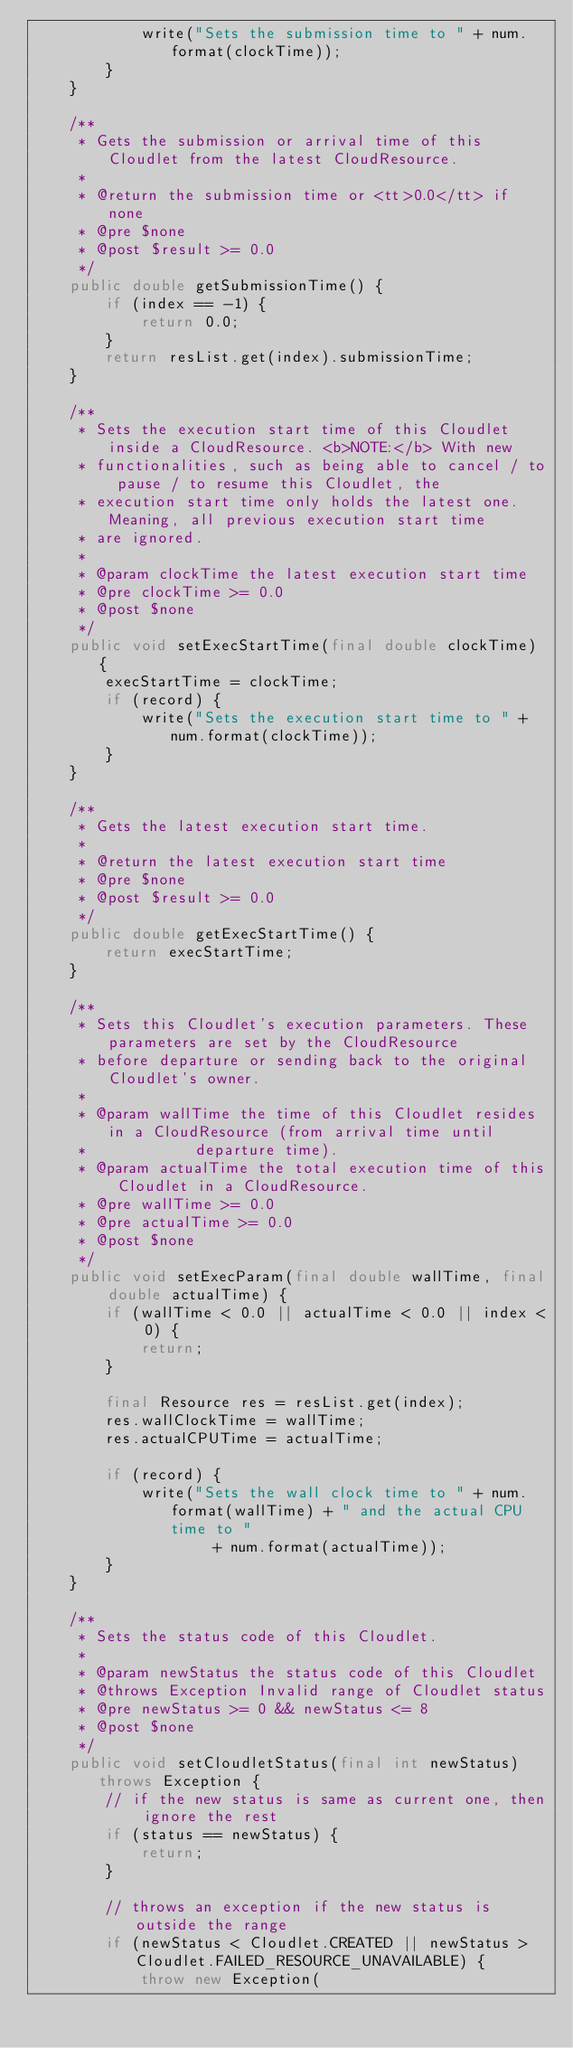Convert code to text. <code><loc_0><loc_0><loc_500><loc_500><_Java_>			write("Sets the submission time to " + num.format(clockTime));
		}
	}

	/**
	 * Gets the submission or arrival time of this Cloudlet from the latest CloudResource.
	 * 
	 * @return the submission time or <tt>0.0</tt> if none
	 * @pre $none
	 * @post $result >= 0.0
	 */
	public double getSubmissionTime() {
		if (index == -1) {
			return 0.0;
		}
		return resList.get(index).submissionTime;
	}

	/**
	 * Sets the execution start time of this Cloudlet inside a CloudResource. <b>NOTE:</b> With new
	 * functionalities, such as being able to cancel / to pause / to resume this Cloudlet, the
	 * execution start time only holds the latest one. Meaning, all previous execution start time
	 * are ignored.
	 * 
	 * @param clockTime the latest execution start time
	 * @pre clockTime >= 0.0
	 * @post $none
	 */
	public void setExecStartTime(final double clockTime) {
		execStartTime = clockTime;
		if (record) {
			write("Sets the execution start time to " + num.format(clockTime));
		}
	}

	/**
	 * Gets the latest execution start time.
	 * 
	 * @return the latest execution start time
	 * @pre $none
	 * @post $result >= 0.0
	 */
	public double getExecStartTime() {
		return execStartTime;
	}

	/**
	 * Sets this Cloudlet's execution parameters. These parameters are set by the CloudResource
	 * before departure or sending back to the original Cloudlet's owner.
	 * 
	 * @param wallTime the time of this Cloudlet resides in a CloudResource (from arrival time until
	 *            departure time).
	 * @param actualTime the total execution time of this Cloudlet in a CloudResource.
	 * @pre wallTime >= 0.0
	 * @pre actualTime >= 0.0
	 * @post $none
	 */
	public void setExecParam(final double wallTime, final double actualTime) {
		if (wallTime < 0.0 || actualTime < 0.0 || index < 0) {
			return;
		}

		final Resource res = resList.get(index);
		res.wallClockTime = wallTime;
		res.actualCPUTime = actualTime;

		if (record) {
			write("Sets the wall clock time to " + num.format(wallTime) + " and the actual CPU time to "
					+ num.format(actualTime));
		}
	}

	/**
	 * Sets the status code of this Cloudlet.
	 * 
	 * @param newStatus the status code of this Cloudlet
	 * @throws Exception Invalid range of Cloudlet status
	 * @pre newStatus >= 0 && newStatus <= 8
	 * @post $none
	 */
	public void setCloudletStatus(final int newStatus) throws Exception {
		// if the new status is same as current one, then ignore the rest
		if (status == newStatus) {
			return;
		}

		// throws an exception if the new status is outside the range
		if (newStatus < Cloudlet.CREATED || newStatus > Cloudlet.FAILED_RESOURCE_UNAVAILABLE) {
			throw new Exception(</code> 